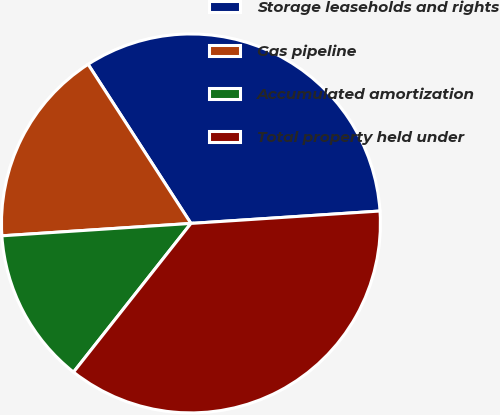Convert chart to OTSL. <chart><loc_0><loc_0><loc_500><loc_500><pie_chart><fcel>Storage leaseholds and rights<fcel>Gas pipeline<fcel>Accumulated amortization<fcel>Total property held under<nl><fcel>33.09%<fcel>16.91%<fcel>13.32%<fcel>36.68%<nl></chart> 